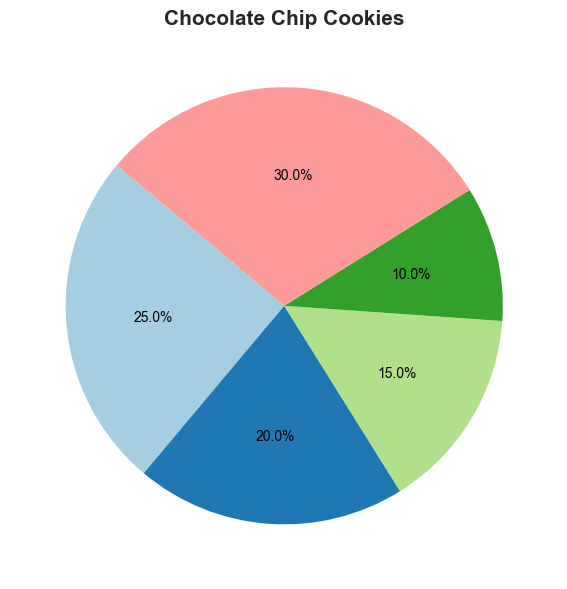What ingredient is used in the highest percentage in Chocolate Chip Cookies, and what is the percentage? From the pie chart for Chocolate Chip Cookies, the ingredient with the largest segment is Chocolate Chips. The percentage shown on the segment is 30%.
Answer: Chocolate Chips, 30% Which recipe uses the highest percentage of Flour, and what is the percentage? Looking at the pie charts for all recipes, Banana Bread has the largest segment for Flour. The percentage indicated on that segment is 40%.
Answer: Banana Bread, 40% Compare the percentage of Butter used in Apple Pie and Blueberry Muffins. Which recipe uses a higher percentage, and by how much? From the pie charts, the segment for Butter in Apple Pie shows 25%, and for Blueberry Muffins, it shows 15%. The difference is 25% - 15% = 10%.
Answer: Apple Pie, 10% What is the total percentage of ingredients that are common between Banana Bread and Blueberry Muffins, and what ingredients are they? The common ingredients between Banana Bread and Blueberry Muffins are Flour, Sugar, Butter, and Eggs. Summing up their percentages in both recipes: For Flour, it is 40% + 35% = 75%. For Sugar, it is 20% + 20% = 40%. For Butter, it is 10% + 15% = 25%. For Eggs, it is 15% + 10% = 25%. Total percentage is 75% + 40% + 25% + 25% = 165%.
Answer: 165%, Flour, Sugar, Butter, Eggs What ingredient is least used in Brownies? In the pie chart for Brownies, the smallest segment represents Butter and Chocolate, both with segments of 20%.
Answer: Butter, Chocolate Compare the ingredient percentages for Sugar in all recipes. Which recipe uses the most Sugar? By examining the pie charts for each recipe, the recipe with the largest segment for Sugar is Brownies, with 25%.
Answer: Brownies, 25% What is the percentage difference between the most-used and the least-used ingredient in Blueberry Muffins? The most-used ingredient in Blueberry Muffins is Flour (35%), and the least-used are Eggs (10%). The percentage difference is 35% - 10% = 25%.
Answer: 25% Which ingredient is used equally in Chocolate Chip Cookies and Apple Pie, and what is the percentage? The ingredient with an equal percentage in both recipes is Sugar. Both segments show a 20% share.
Answer: Sugar, 20% What is the combined percentage of all types of fruit ingredients (Bananas, Blueberries, Apples, Chocolate Chips, Chocolate) used across all recipes? From the pie charts, the percentages are as follows: Chocolate Chips (30% in Chocolate Chip Cookies), Bananas (15% in Banana Bread), Blueberries (20% in Blueberry Muffins), Apples (20% in Apple Pie), and Chocolate (20% in Brownies). Total percentage is 30% + 15% + 20% + 20% + 20% = 105%.
Answer: 105% 